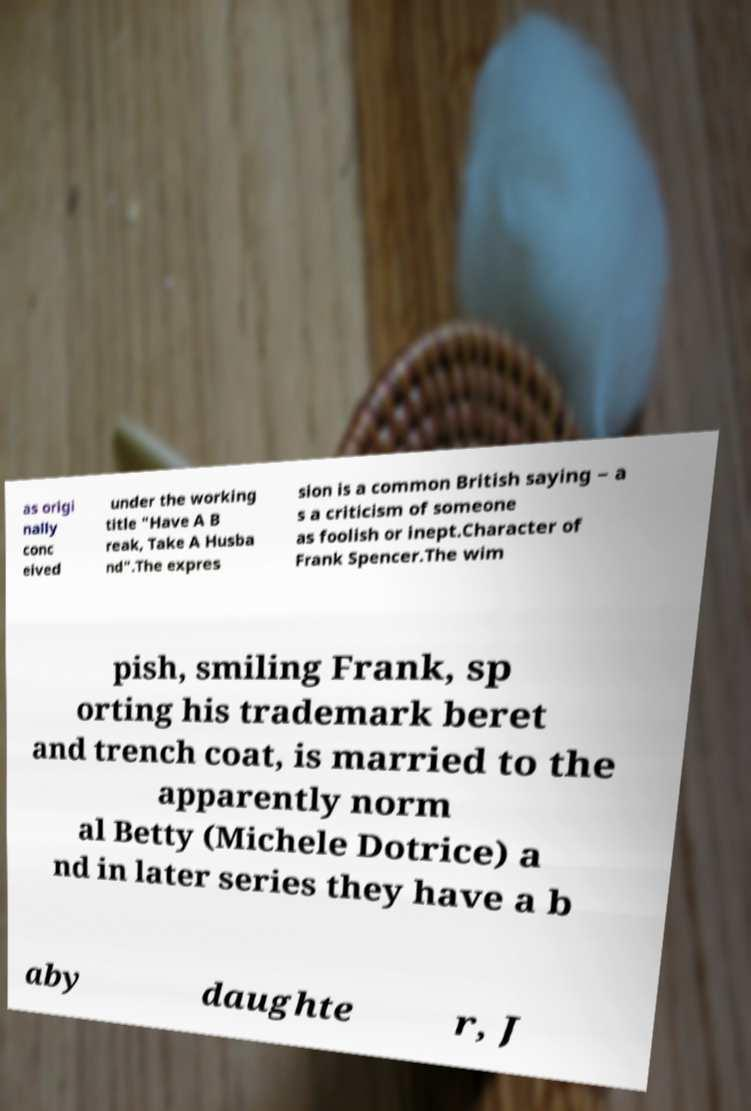For documentation purposes, I need the text within this image transcribed. Could you provide that? as origi nally conc eived under the working title "Have A B reak, Take A Husba nd".The expres sion is a common British saying – a s a criticism of someone as foolish or inept.Character of Frank Spencer.The wim pish, smiling Frank, sp orting his trademark beret and trench coat, is married to the apparently norm al Betty (Michele Dotrice) a nd in later series they have a b aby daughte r, J 